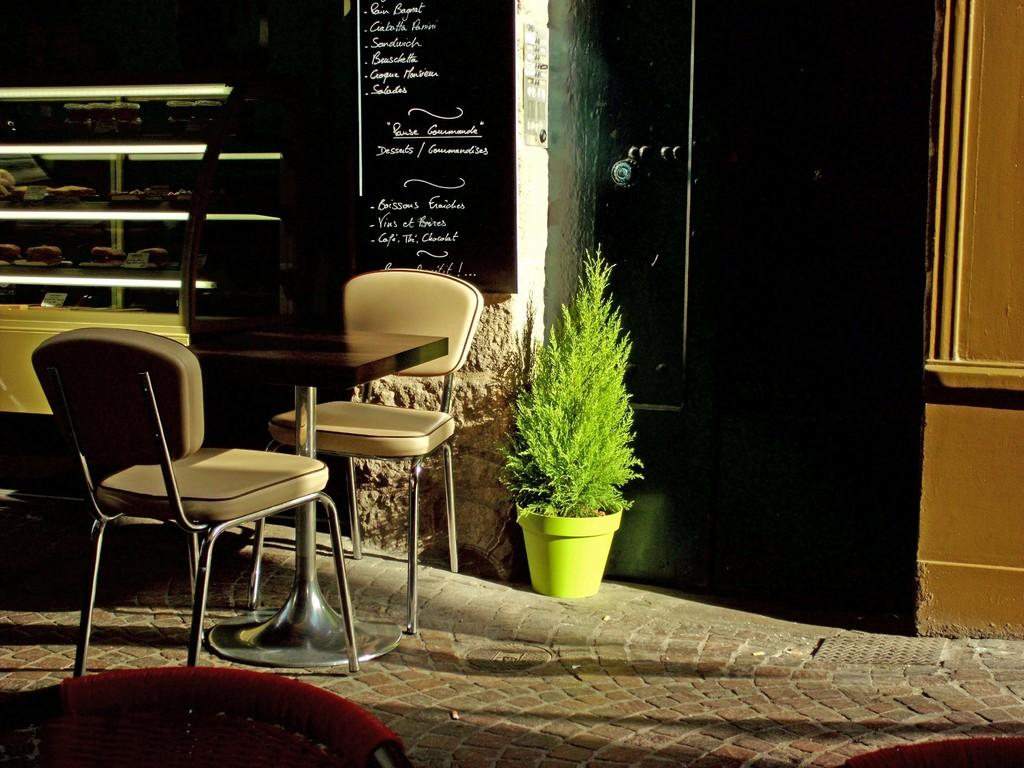How many chairs are in the image? There are two chairs in the image. What is the furniture piece located between the chairs? There is a table in the image. What type of greenery is present in the image? There is a plant in the image. What can be seen on the wall in the image? There is a menu board on the wall in the image. What type of structure is visible in the background of the image? There is a building visible in the image. How does the pen help with digestion in the image? There is no pen present in the image, and therefore no such assistance with digestion can be observed. 